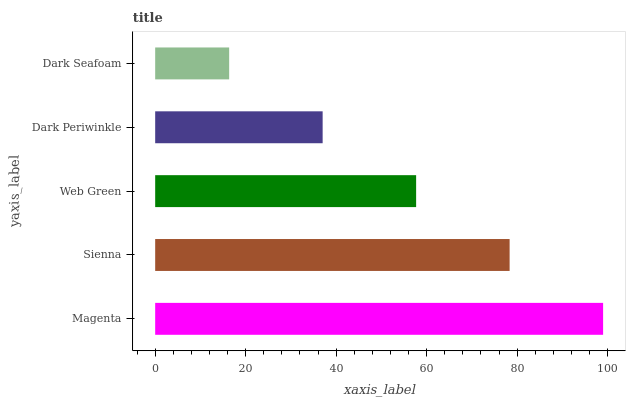Is Dark Seafoam the minimum?
Answer yes or no. Yes. Is Magenta the maximum?
Answer yes or no. Yes. Is Sienna the minimum?
Answer yes or no. No. Is Sienna the maximum?
Answer yes or no. No. Is Magenta greater than Sienna?
Answer yes or no. Yes. Is Sienna less than Magenta?
Answer yes or no. Yes. Is Sienna greater than Magenta?
Answer yes or no. No. Is Magenta less than Sienna?
Answer yes or no. No. Is Web Green the high median?
Answer yes or no. Yes. Is Web Green the low median?
Answer yes or no. Yes. Is Sienna the high median?
Answer yes or no. No. Is Dark Periwinkle the low median?
Answer yes or no. No. 